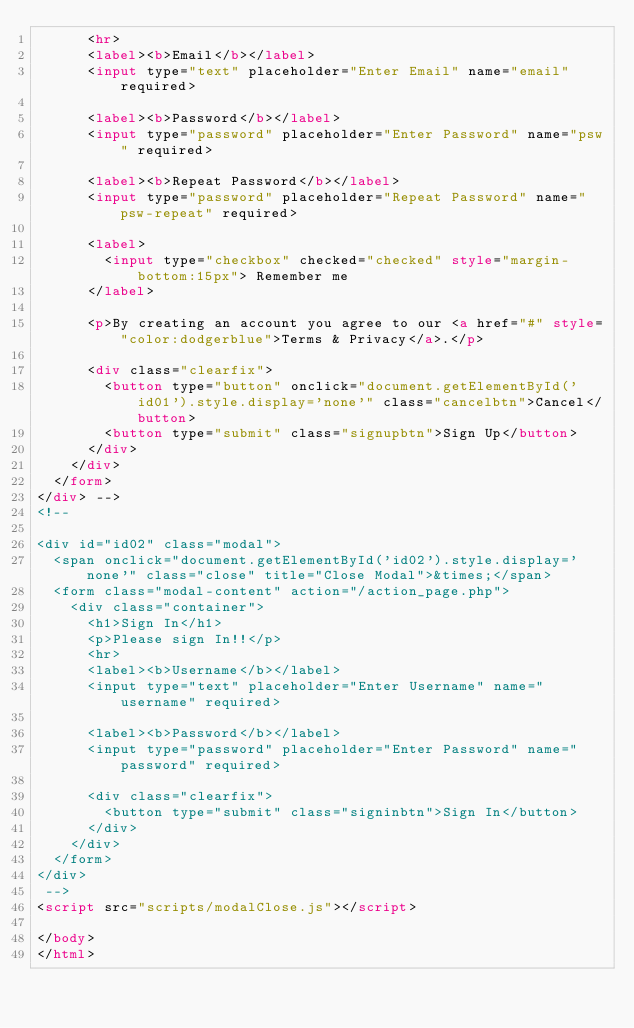<code> <loc_0><loc_0><loc_500><loc_500><_HTML_>      <hr>
      <label><b>Email</b></label>
      <input type="text" placeholder="Enter Email" name="email" required>

      <label><b>Password</b></label>
      <input type="password" placeholder="Enter Password" name="psw" required>

      <label><b>Repeat Password</b></label>
      <input type="password" placeholder="Repeat Password" name="psw-repeat" required>
      
      <label>
        <input type="checkbox" checked="checked" style="margin-bottom:15px"> Remember me
      </label>

      <p>By creating an account you agree to our <a href="#" style="color:dodgerblue">Terms & Privacy</a>.</p>

      <div class="clearfix">
        <button type="button" onclick="document.getElementById('id01').style.display='none'" class="cancelbtn">Cancel</button>
        <button type="submit" class="signupbtn">Sign Up</button>
      </div>
    </div>
  </form>
</div> -->
<!-- 

<div id="id02" class="modal">
  <span onclick="document.getElementById('id02').style.display='none'" class="close" title="Close Modal">&times;</span>
  <form class="modal-content" action="/action_page.php">
    <div class="container">
      <h1>Sign In</h1>
      <p>Please sign In!!</p>
      <hr>
      <label><b>Username</b></label>
      <input type="text" placeholder="Enter Username" name="username" required>

      <label><b>Password</b></label>
      <input type="password" placeholder="Enter Password" name="password" required>

      <div class="clearfix">
        <button type="submit" class="signinbtn">Sign In</button>
      </div>
    </div>
  </form>
</div>
 -->
<script src="scripts/modalClose.js"></script>

</body>
</html>
</code> 